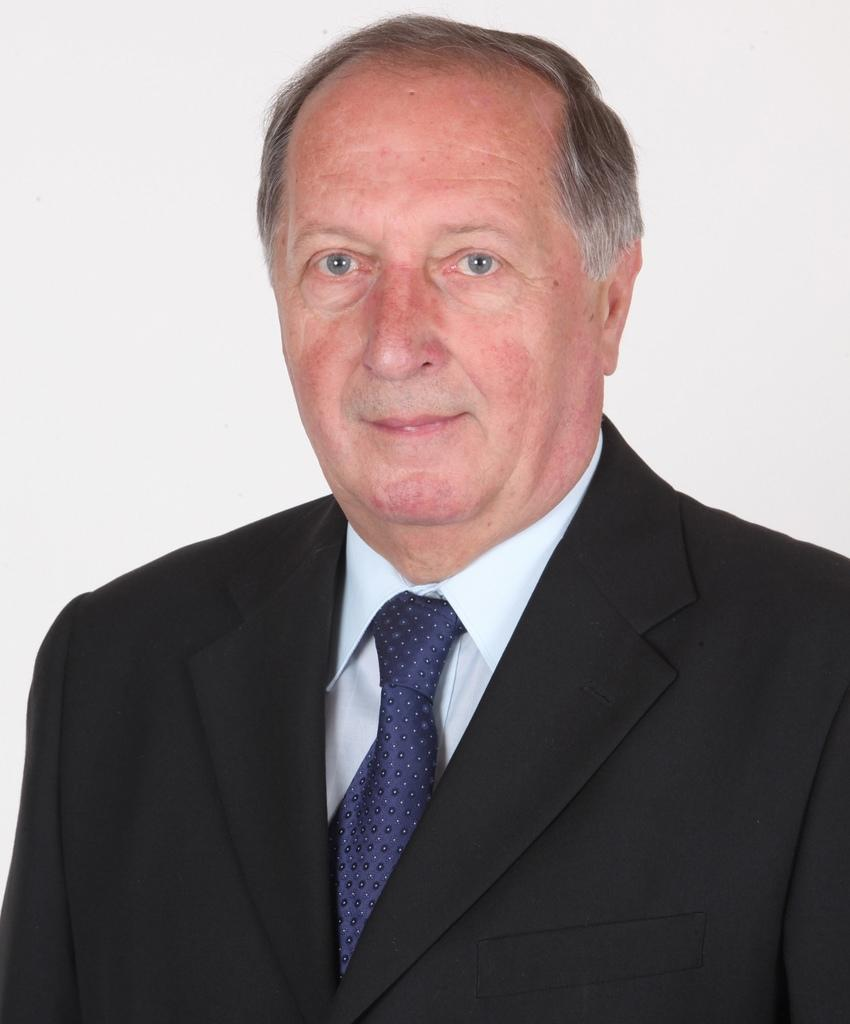What is the main subject of the picture? The main subject of the picture is a man. What is the man wearing on his upper body? The man is wearing a shirt, a tie, and a coat. What is the color of the background in the image? The background of the image is white in color. What type of destruction can be seen in the image? There is no destruction present in the image; it features a man wearing a shirt, tie, and coat against a white background. What kind of crack is visible on the man's clothing in the image? There is no crack visible on the man's clothing in the image. 